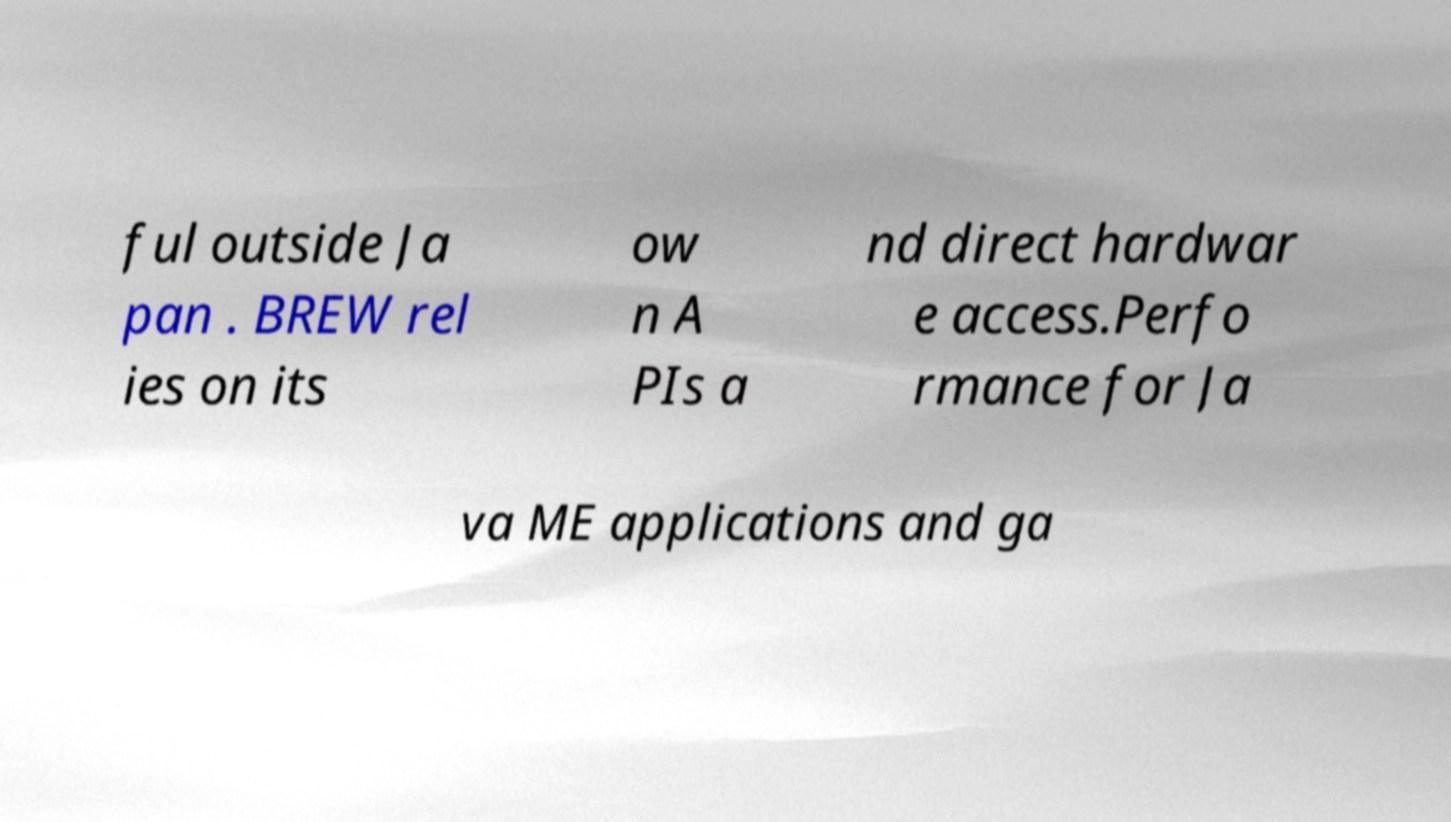Could you extract and type out the text from this image? ful outside Ja pan . BREW rel ies on its ow n A PIs a nd direct hardwar e access.Perfo rmance for Ja va ME applications and ga 